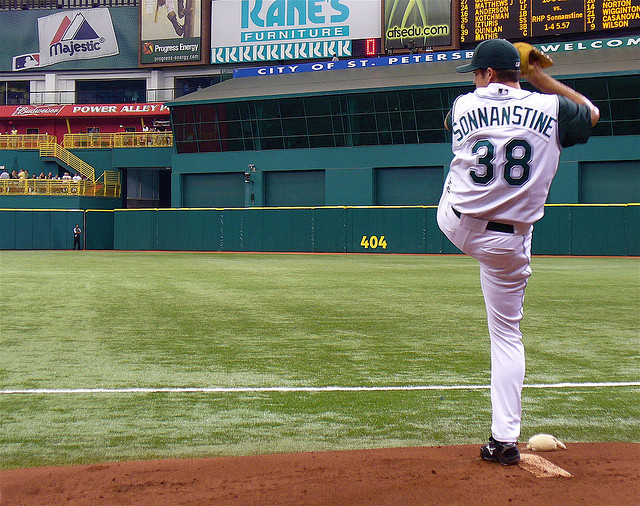Please extract the text content from this image. CITY OF S T FURNIURE 404 WILSON CASANOYA WINGGINTON NORTON 9 17 21 14 38 SONNANSTINE WELCOM PETERSB 5.57 1-4 vs. RHP c LF ZTURNS KOTCHMAN ANDERSON 39 24 afsedu.com 0 KKKKKKKKKK KANES ALLEY POWER Majestic 